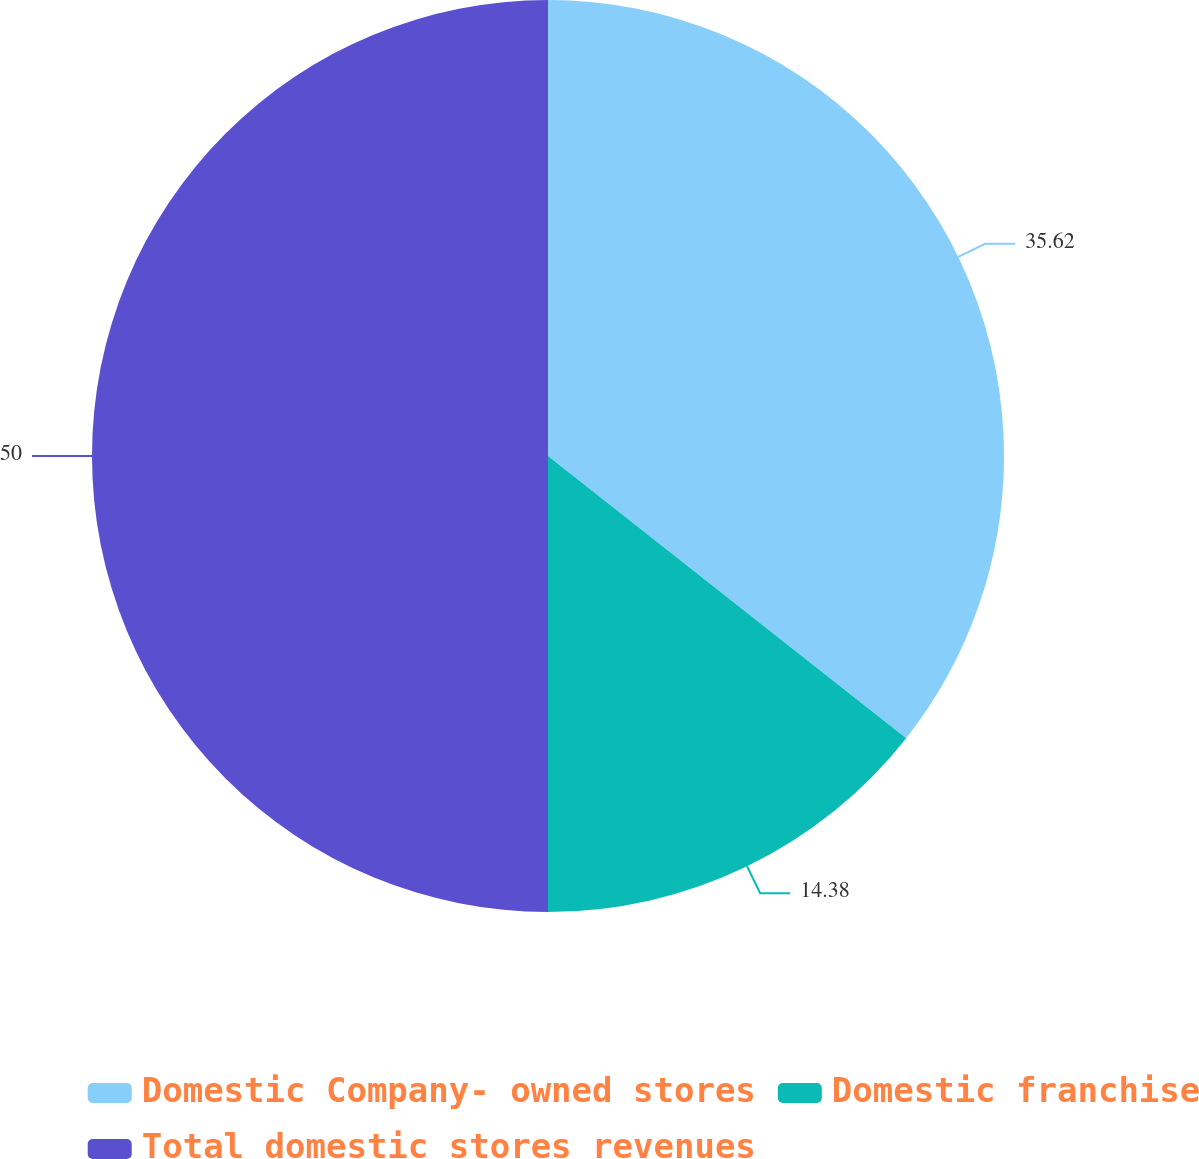Convert chart. <chart><loc_0><loc_0><loc_500><loc_500><pie_chart><fcel>Domestic Company- owned stores<fcel>Domestic franchise<fcel>Total domestic stores revenues<nl><fcel>35.62%<fcel>14.38%<fcel>50.0%<nl></chart> 